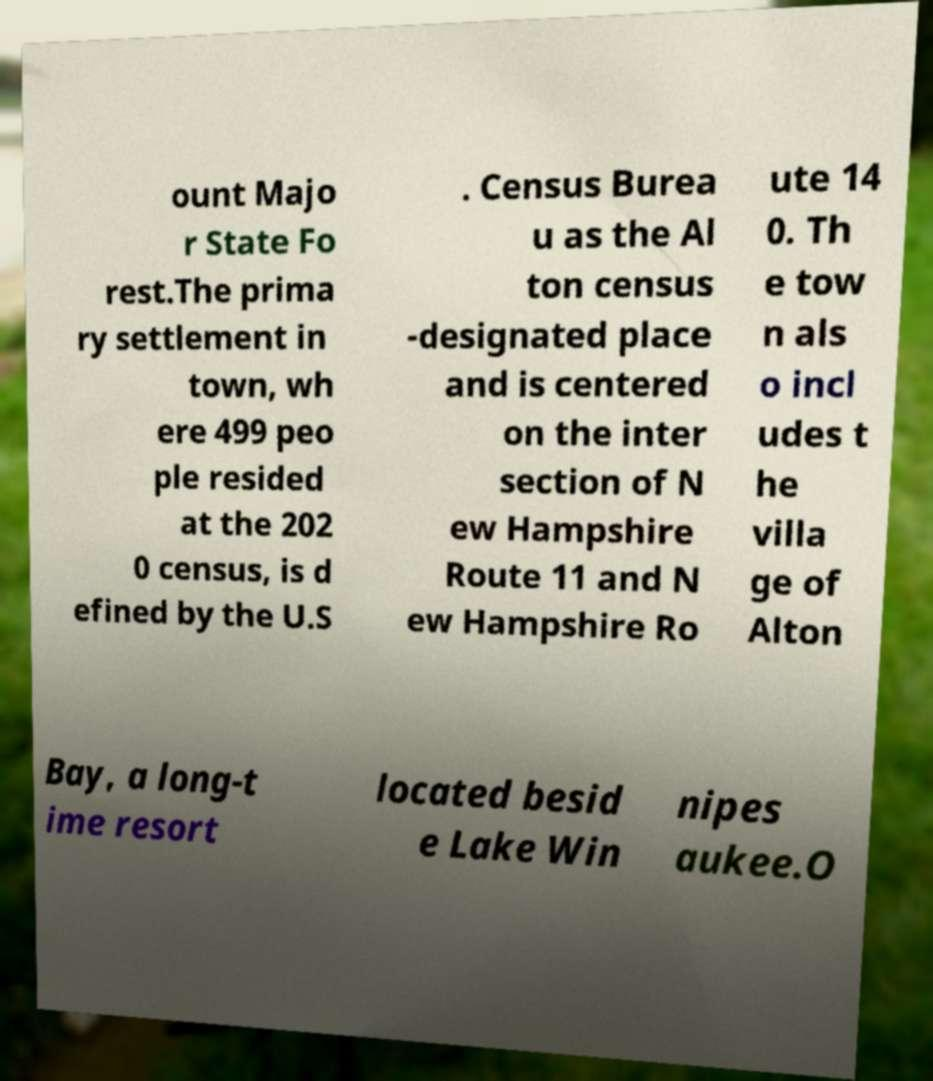There's text embedded in this image that I need extracted. Can you transcribe it verbatim? ount Majo r State Fo rest.The prima ry settlement in town, wh ere 499 peo ple resided at the 202 0 census, is d efined by the U.S . Census Burea u as the Al ton census -designated place and is centered on the inter section of N ew Hampshire Route 11 and N ew Hampshire Ro ute 14 0. Th e tow n als o incl udes t he villa ge of Alton Bay, a long-t ime resort located besid e Lake Win nipes aukee.O 